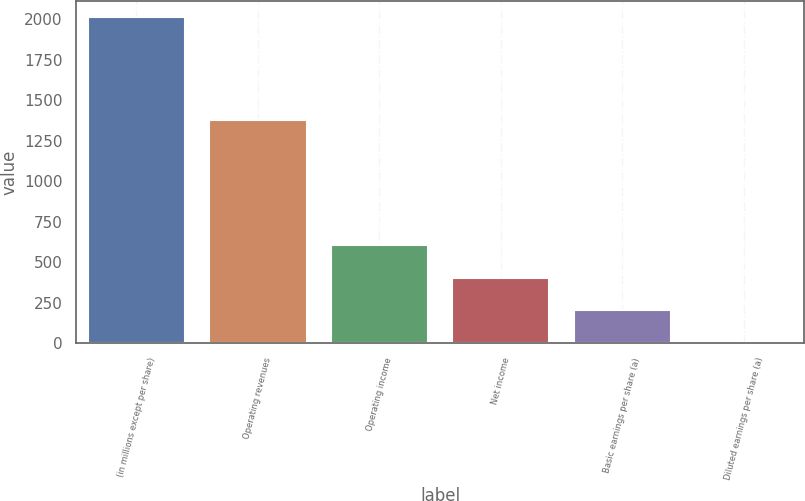Convert chart to OTSL. <chart><loc_0><loc_0><loc_500><loc_500><bar_chart><fcel>(in millions except per share)<fcel>Operating revenues<fcel>Operating income<fcel>Net income<fcel>Basic earnings per share (a)<fcel>Diluted earnings per share (a)<nl><fcel>2015<fcel>1377<fcel>605.56<fcel>404.21<fcel>202.86<fcel>1.51<nl></chart> 